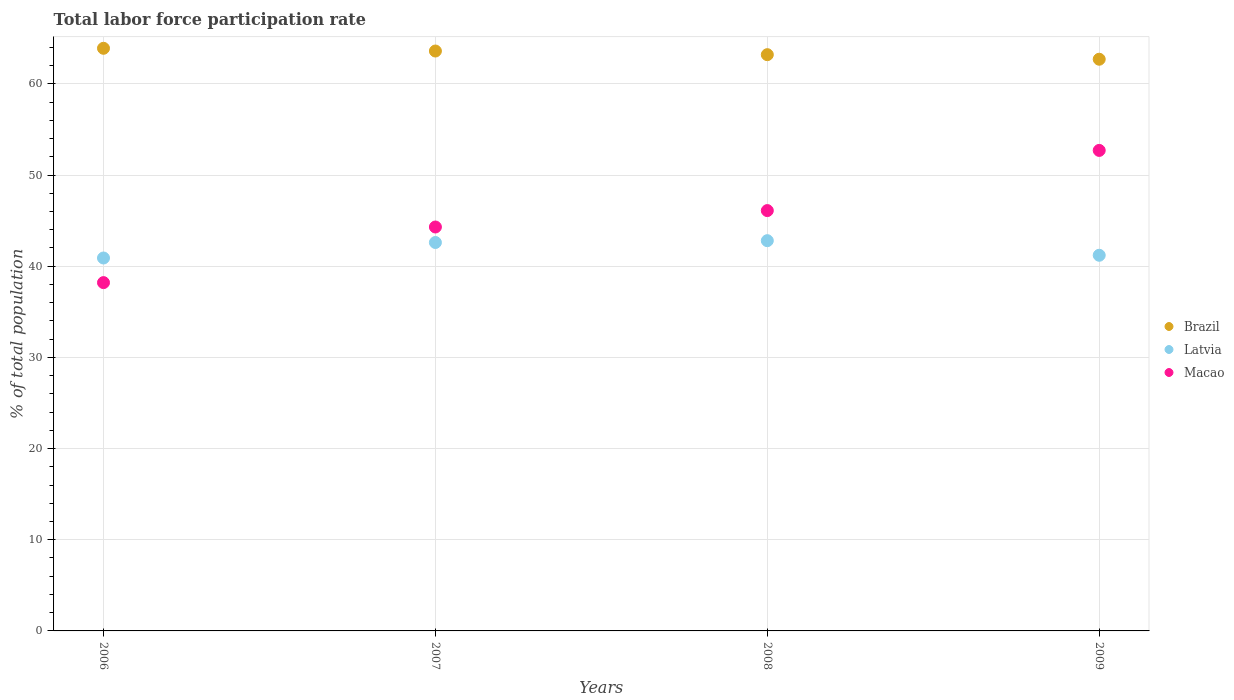How many different coloured dotlines are there?
Make the answer very short. 3. What is the total labor force participation rate in Macao in 2006?
Make the answer very short. 38.2. Across all years, what is the maximum total labor force participation rate in Macao?
Keep it short and to the point. 52.7. Across all years, what is the minimum total labor force participation rate in Latvia?
Offer a terse response. 40.9. What is the total total labor force participation rate in Macao in the graph?
Offer a terse response. 181.3. What is the difference between the total labor force participation rate in Brazil in 2006 and that in 2008?
Keep it short and to the point. 0.7. What is the difference between the total labor force participation rate in Macao in 2008 and the total labor force participation rate in Latvia in 2007?
Your answer should be compact. 3.5. What is the average total labor force participation rate in Brazil per year?
Provide a short and direct response. 63.35. In the year 2006, what is the difference between the total labor force participation rate in Latvia and total labor force participation rate in Macao?
Provide a succinct answer. 2.7. What is the ratio of the total labor force participation rate in Macao in 2006 to that in 2009?
Ensure brevity in your answer.  0.72. What is the difference between the highest and the second highest total labor force participation rate in Macao?
Your answer should be very brief. 6.6. What is the difference between the highest and the lowest total labor force participation rate in Macao?
Offer a terse response. 14.5. Does the total labor force participation rate in Brazil monotonically increase over the years?
Your response must be concise. No. Is the total labor force participation rate in Latvia strictly less than the total labor force participation rate in Macao over the years?
Give a very brief answer. No. How many dotlines are there?
Give a very brief answer. 3. How many years are there in the graph?
Keep it short and to the point. 4. Does the graph contain grids?
Offer a very short reply. Yes. How many legend labels are there?
Make the answer very short. 3. How are the legend labels stacked?
Provide a succinct answer. Vertical. What is the title of the graph?
Provide a succinct answer. Total labor force participation rate. Does "Suriname" appear as one of the legend labels in the graph?
Offer a terse response. No. What is the label or title of the Y-axis?
Keep it short and to the point. % of total population. What is the % of total population of Brazil in 2006?
Keep it short and to the point. 63.9. What is the % of total population of Latvia in 2006?
Keep it short and to the point. 40.9. What is the % of total population of Macao in 2006?
Your answer should be very brief. 38.2. What is the % of total population in Brazil in 2007?
Give a very brief answer. 63.6. What is the % of total population in Latvia in 2007?
Provide a succinct answer. 42.6. What is the % of total population of Macao in 2007?
Provide a short and direct response. 44.3. What is the % of total population in Brazil in 2008?
Make the answer very short. 63.2. What is the % of total population in Latvia in 2008?
Give a very brief answer. 42.8. What is the % of total population of Macao in 2008?
Your response must be concise. 46.1. What is the % of total population of Brazil in 2009?
Your answer should be very brief. 62.7. What is the % of total population in Latvia in 2009?
Your response must be concise. 41.2. What is the % of total population of Macao in 2009?
Offer a very short reply. 52.7. Across all years, what is the maximum % of total population of Brazil?
Offer a terse response. 63.9. Across all years, what is the maximum % of total population in Latvia?
Offer a terse response. 42.8. Across all years, what is the maximum % of total population of Macao?
Make the answer very short. 52.7. Across all years, what is the minimum % of total population in Brazil?
Offer a terse response. 62.7. Across all years, what is the minimum % of total population of Latvia?
Your response must be concise. 40.9. Across all years, what is the minimum % of total population in Macao?
Your answer should be very brief. 38.2. What is the total % of total population in Brazil in the graph?
Your answer should be compact. 253.4. What is the total % of total population in Latvia in the graph?
Provide a succinct answer. 167.5. What is the total % of total population of Macao in the graph?
Your answer should be compact. 181.3. What is the difference between the % of total population of Brazil in 2006 and that in 2007?
Offer a very short reply. 0.3. What is the difference between the % of total population in Macao in 2006 and that in 2007?
Offer a very short reply. -6.1. What is the difference between the % of total population in Latvia in 2006 and that in 2008?
Ensure brevity in your answer.  -1.9. What is the difference between the % of total population in Brazil in 2006 and that in 2009?
Your answer should be very brief. 1.2. What is the difference between the % of total population in Latvia in 2006 and that in 2009?
Your response must be concise. -0.3. What is the difference between the % of total population of Brazil in 2007 and that in 2008?
Your response must be concise. 0.4. What is the difference between the % of total population in Latvia in 2007 and that in 2008?
Your response must be concise. -0.2. What is the difference between the % of total population of Brazil in 2008 and that in 2009?
Offer a very short reply. 0.5. What is the difference between the % of total population in Macao in 2008 and that in 2009?
Make the answer very short. -6.6. What is the difference between the % of total population of Brazil in 2006 and the % of total population of Latvia in 2007?
Give a very brief answer. 21.3. What is the difference between the % of total population in Brazil in 2006 and the % of total population in Macao in 2007?
Ensure brevity in your answer.  19.6. What is the difference between the % of total population of Latvia in 2006 and the % of total population of Macao in 2007?
Make the answer very short. -3.4. What is the difference between the % of total population of Brazil in 2006 and the % of total population of Latvia in 2008?
Your response must be concise. 21.1. What is the difference between the % of total population in Brazil in 2006 and the % of total population in Macao in 2008?
Provide a succinct answer. 17.8. What is the difference between the % of total population of Latvia in 2006 and the % of total population of Macao in 2008?
Offer a terse response. -5.2. What is the difference between the % of total population in Brazil in 2006 and the % of total population in Latvia in 2009?
Offer a terse response. 22.7. What is the difference between the % of total population of Brazil in 2006 and the % of total population of Macao in 2009?
Your answer should be compact. 11.2. What is the difference between the % of total population of Latvia in 2006 and the % of total population of Macao in 2009?
Make the answer very short. -11.8. What is the difference between the % of total population in Brazil in 2007 and the % of total population in Latvia in 2008?
Provide a short and direct response. 20.8. What is the difference between the % of total population in Latvia in 2007 and the % of total population in Macao in 2008?
Make the answer very short. -3.5. What is the difference between the % of total population in Brazil in 2007 and the % of total population in Latvia in 2009?
Make the answer very short. 22.4. What is the difference between the % of total population in Brazil in 2007 and the % of total population in Macao in 2009?
Your response must be concise. 10.9. What is the difference between the % of total population of Latvia in 2007 and the % of total population of Macao in 2009?
Ensure brevity in your answer.  -10.1. What is the difference between the % of total population in Brazil in 2008 and the % of total population in Latvia in 2009?
Provide a short and direct response. 22. What is the difference between the % of total population in Brazil in 2008 and the % of total population in Macao in 2009?
Your answer should be very brief. 10.5. What is the average % of total population in Brazil per year?
Your response must be concise. 63.35. What is the average % of total population in Latvia per year?
Keep it short and to the point. 41.88. What is the average % of total population of Macao per year?
Ensure brevity in your answer.  45.33. In the year 2006, what is the difference between the % of total population of Brazil and % of total population of Latvia?
Give a very brief answer. 23. In the year 2006, what is the difference between the % of total population of Brazil and % of total population of Macao?
Offer a very short reply. 25.7. In the year 2007, what is the difference between the % of total population of Brazil and % of total population of Macao?
Provide a short and direct response. 19.3. In the year 2008, what is the difference between the % of total population of Brazil and % of total population of Latvia?
Your answer should be very brief. 20.4. In the year 2008, what is the difference between the % of total population of Brazil and % of total population of Macao?
Provide a short and direct response. 17.1. In the year 2008, what is the difference between the % of total population of Latvia and % of total population of Macao?
Provide a succinct answer. -3.3. What is the ratio of the % of total population in Brazil in 2006 to that in 2007?
Your answer should be compact. 1. What is the ratio of the % of total population of Latvia in 2006 to that in 2007?
Your response must be concise. 0.96. What is the ratio of the % of total population in Macao in 2006 to that in 2007?
Your answer should be very brief. 0.86. What is the ratio of the % of total population in Brazil in 2006 to that in 2008?
Offer a very short reply. 1.01. What is the ratio of the % of total population of Latvia in 2006 to that in 2008?
Your response must be concise. 0.96. What is the ratio of the % of total population in Macao in 2006 to that in 2008?
Your answer should be compact. 0.83. What is the ratio of the % of total population in Brazil in 2006 to that in 2009?
Your response must be concise. 1.02. What is the ratio of the % of total population of Macao in 2006 to that in 2009?
Keep it short and to the point. 0.72. What is the ratio of the % of total population of Macao in 2007 to that in 2008?
Make the answer very short. 0.96. What is the ratio of the % of total population of Brazil in 2007 to that in 2009?
Your answer should be very brief. 1.01. What is the ratio of the % of total population in Latvia in 2007 to that in 2009?
Keep it short and to the point. 1.03. What is the ratio of the % of total population of Macao in 2007 to that in 2009?
Give a very brief answer. 0.84. What is the ratio of the % of total population in Brazil in 2008 to that in 2009?
Keep it short and to the point. 1.01. What is the ratio of the % of total population in Latvia in 2008 to that in 2009?
Your answer should be very brief. 1.04. What is the ratio of the % of total population of Macao in 2008 to that in 2009?
Ensure brevity in your answer.  0.87. What is the difference between the highest and the second highest % of total population of Macao?
Offer a terse response. 6.6. What is the difference between the highest and the lowest % of total population of Brazil?
Make the answer very short. 1.2. 